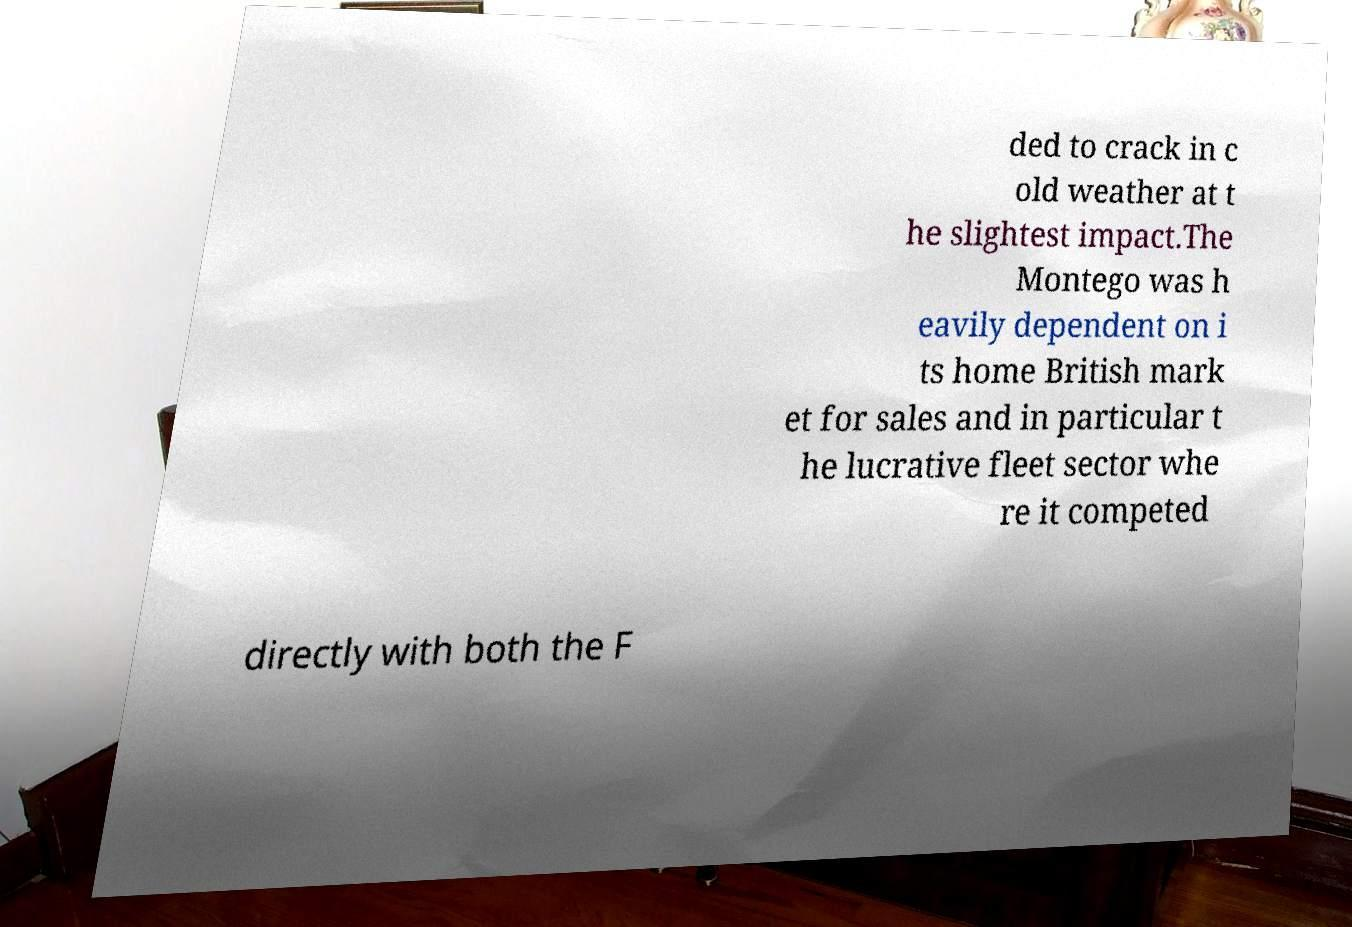I need the written content from this picture converted into text. Can you do that? ded to crack in c old weather at t he slightest impact.The Montego was h eavily dependent on i ts home British mark et for sales and in particular t he lucrative fleet sector whe re it competed directly with both the F 